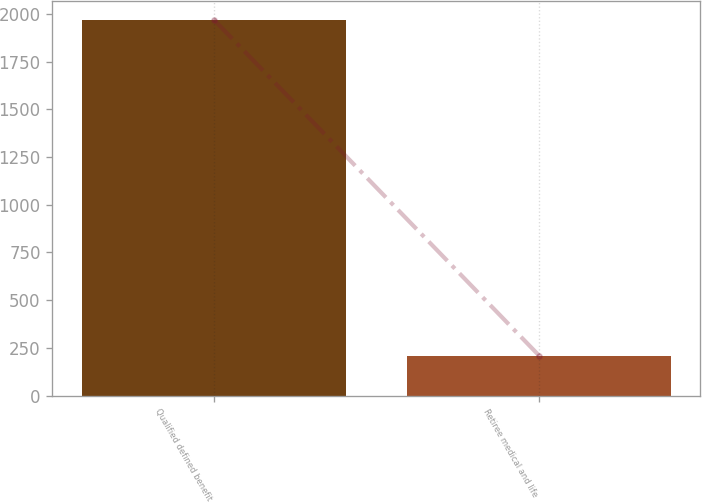Convert chart to OTSL. <chart><loc_0><loc_0><loc_500><loc_500><bar_chart><fcel>Qualified defined benefit<fcel>Retiree medical and life<nl><fcel>1970<fcel>210<nl></chart> 